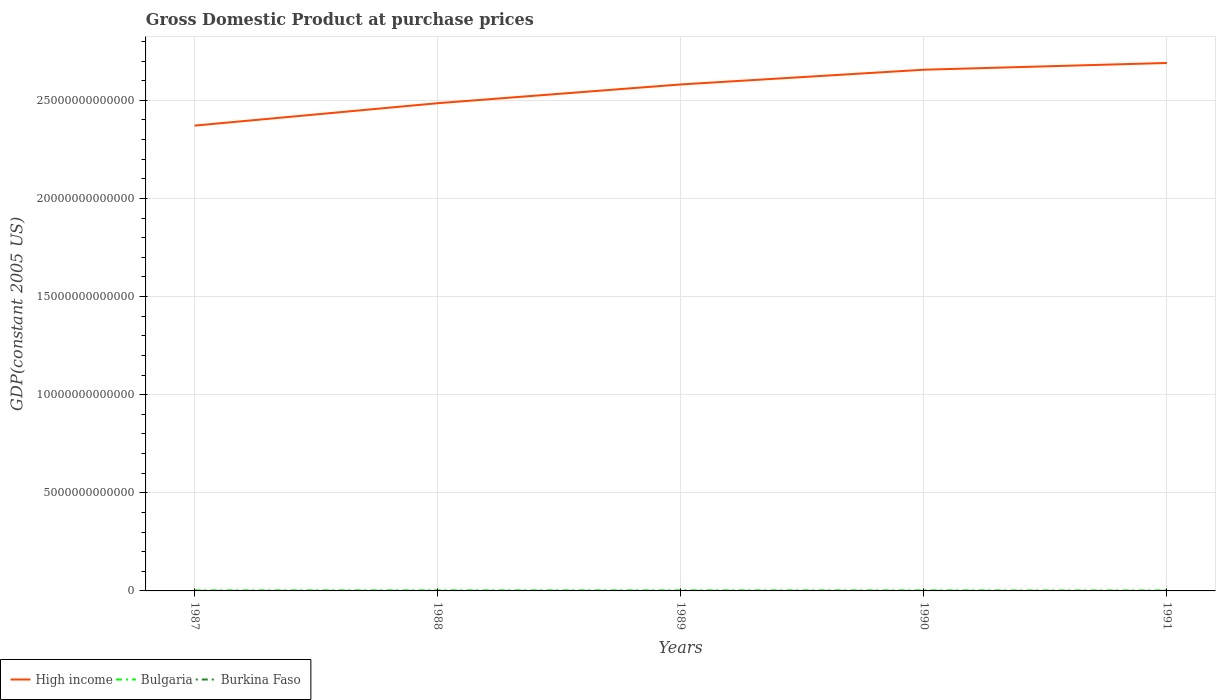Is the number of lines equal to the number of legend labels?
Offer a terse response. Yes. Across all years, what is the maximum GDP at purchase prices in High income?
Provide a short and direct response. 2.37e+13. In which year was the GDP at purchase prices in High income maximum?
Offer a terse response. 1987. What is the total GDP at purchase prices in Bulgaria in the graph?
Your answer should be very brief. 5.53e+09. What is the difference between the highest and the second highest GDP at purchase prices in Burkina Faso?
Make the answer very short. 3.82e+08. How many lines are there?
Ensure brevity in your answer.  3. How many years are there in the graph?
Your answer should be compact. 5. What is the difference between two consecutive major ticks on the Y-axis?
Provide a succinct answer. 5.00e+12. Are the values on the major ticks of Y-axis written in scientific E-notation?
Offer a very short reply. No. Does the graph contain any zero values?
Provide a succinct answer. No. Does the graph contain grids?
Your response must be concise. Yes. How are the legend labels stacked?
Provide a succinct answer. Horizontal. What is the title of the graph?
Provide a succinct answer. Gross Domestic Product at purchase prices. Does "Norway" appear as one of the legend labels in the graph?
Ensure brevity in your answer.  No. What is the label or title of the Y-axis?
Your answer should be very brief. GDP(constant 2005 US). What is the GDP(constant 2005 US) of High income in 1987?
Provide a succinct answer. 2.37e+13. What is the GDP(constant 2005 US) of Bulgaria in 1987?
Offer a terse response. 2.55e+1. What is the GDP(constant 2005 US) of Burkina Faso in 1987?
Your answer should be very brief. 2.23e+09. What is the GDP(constant 2005 US) in High income in 1988?
Your response must be concise. 2.49e+13. What is the GDP(constant 2005 US) of Bulgaria in 1988?
Keep it short and to the point. 2.83e+1. What is the GDP(constant 2005 US) in Burkina Faso in 1988?
Your answer should be very brief. 2.35e+09. What is the GDP(constant 2005 US) in High income in 1989?
Your answer should be compact. 2.58e+13. What is the GDP(constant 2005 US) of Bulgaria in 1989?
Your answer should be compact. 2.74e+1. What is the GDP(constant 2005 US) of Burkina Faso in 1989?
Ensure brevity in your answer.  2.41e+09. What is the GDP(constant 2005 US) of High income in 1990?
Make the answer very short. 2.66e+13. What is the GDP(constant 2005 US) in Bulgaria in 1990?
Provide a succinct answer. 2.49e+1. What is the GDP(constant 2005 US) of Burkina Faso in 1990?
Your answer should be very brief. 2.39e+09. What is the GDP(constant 2005 US) in High income in 1991?
Make the answer very short. 2.69e+13. What is the GDP(constant 2005 US) in Bulgaria in 1991?
Offer a very short reply. 2.28e+1. What is the GDP(constant 2005 US) in Burkina Faso in 1991?
Give a very brief answer. 2.61e+09. Across all years, what is the maximum GDP(constant 2005 US) in High income?
Make the answer very short. 2.69e+13. Across all years, what is the maximum GDP(constant 2005 US) of Bulgaria?
Your answer should be compact. 2.83e+1. Across all years, what is the maximum GDP(constant 2005 US) in Burkina Faso?
Your answer should be very brief. 2.61e+09. Across all years, what is the minimum GDP(constant 2005 US) of High income?
Your response must be concise. 2.37e+13. Across all years, what is the minimum GDP(constant 2005 US) of Bulgaria?
Provide a succinct answer. 2.28e+1. Across all years, what is the minimum GDP(constant 2005 US) in Burkina Faso?
Your answer should be very brief. 2.23e+09. What is the total GDP(constant 2005 US) in High income in the graph?
Make the answer very short. 1.28e+14. What is the total GDP(constant 2005 US) of Bulgaria in the graph?
Provide a short and direct response. 1.29e+11. What is the total GDP(constant 2005 US) of Burkina Faso in the graph?
Your response must be concise. 1.20e+1. What is the difference between the GDP(constant 2005 US) of High income in 1987 and that in 1988?
Ensure brevity in your answer.  -1.14e+12. What is the difference between the GDP(constant 2005 US) in Bulgaria in 1987 and that in 1988?
Offer a terse response. -2.79e+09. What is the difference between the GDP(constant 2005 US) of Burkina Faso in 1987 and that in 1988?
Your answer should be very brief. -1.29e+08. What is the difference between the GDP(constant 2005 US) of High income in 1987 and that in 1989?
Offer a terse response. -2.10e+12. What is the difference between the GDP(constant 2005 US) in Bulgaria in 1987 and that in 1989?
Offer a terse response. -1.86e+09. What is the difference between the GDP(constant 2005 US) of Burkina Faso in 1987 and that in 1989?
Provide a succinct answer. -1.80e+08. What is the difference between the GDP(constant 2005 US) of High income in 1987 and that in 1990?
Provide a succinct answer. -2.85e+12. What is the difference between the GDP(constant 2005 US) in Bulgaria in 1987 and that in 1990?
Your response must be concise. 6.35e+08. What is the difference between the GDP(constant 2005 US) in Burkina Faso in 1987 and that in 1990?
Keep it short and to the point. -1.65e+08. What is the difference between the GDP(constant 2005 US) in High income in 1987 and that in 1991?
Offer a terse response. -3.19e+12. What is the difference between the GDP(constant 2005 US) of Bulgaria in 1987 and that in 1991?
Make the answer very short. 2.74e+09. What is the difference between the GDP(constant 2005 US) in Burkina Faso in 1987 and that in 1991?
Provide a short and direct response. -3.82e+08. What is the difference between the GDP(constant 2005 US) in High income in 1988 and that in 1989?
Keep it short and to the point. -9.55e+11. What is the difference between the GDP(constant 2005 US) in Bulgaria in 1988 and that in 1989?
Give a very brief answer. 9.32e+08. What is the difference between the GDP(constant 2005 US) of Burkina Faso in 1988 and that in 1989?
Your answer should be very brief. -5.06e+07. What is the difference between the GDP(constant 2005 US) of High income in 1988 and that in 1990?
Keep it short and to the point. -1.71e+12. What is the difference between the GDP(constant 2005 US) in Bulgaria in 1988 and that in 1990?
Give a very brief answer. 3.43e+09. What is the difference between the GDP(constant 2005 US) of Burkina Faso in 1988 and that in 1990?
Your answer should be very brief. -3.61e+07. What is the difference between the GDP(constant 2005 US) in High income in 1988 and that in 1991?
Keep it short and to the point. -2.05e+12. What is the difference between the GDP(constant 2005 US) in Bulgaria in 1988 and that in 1991?
Your response must be concise. 5.53e+09. What is the difference between the GDP(constant 2005 US) of Burkina Faso in 1988 and that in 1991?
Provide a short and direct response. -2.53e+08. What is the difference between the GDP(constant 2005 US) of High income in 1989 and that in 1990?
Your answer should be compact. -7.51e+11. What is the difference between the GDP(constant 2005 US) of Bulgaria in 1989 and that in 1990?
Keep it short and to the point. 2.50e+09. What is the difference between the GDP(constant 2005 US) of Burkina Faso in 1989 and that in 1990?
Ensure brevity in your answer.  1.45e+07. What is the difference between the GDP(constant 2005 US) of High income in 1989 and that in 1991?
Provide a short and direct response. -1.09e+12. What is the difference between the GDP(constant 2005 US) in Bulgaria in 1989 and that in 1991?
Provide a succinct answer. 4.60e+09. What is the difference between the GDP(constant 2005 US) in Burkina Faso in 1989 and that in 1991?
Ensure brevity in your answer.  -2.02e+08. What is the difference between the GDP(constant 2005 US) of High income in 1990 and that in 1991?
Your answer should be very brief. -3.44e+11. What is the difference between the GDP(constant 2005 US) of Bulgaria in 1990 and that in 1991?
Give a very brief answer. 2.10e+09. What is the difference between the GDP(constant 2005 US) of Burkina Faso in 1990 and that in 1991?
Your answer should be very brief. -2.17e+08. What is the difference between the GDP(constant 2005 US) in High income in 1987 and the GDP(constant 2005 US) in Bulgaria in 1988?
Give a very brief answer. 2.37e+13. What is the difference between the GDP(constant 2005 US) in High income in 1987 and the GDP(constant 2005 US) in Burkina Faso in 1988?
Provide a short and direct response. 2.37e+13. What is the difference between the GDP(constant 2005 US) of Bulgaria in 1987 and the GDP(constant 2005 US) of Burkina Faso in 1988?
Ensure brevity in your answer.  2.32e+1. What is the difference between the GDP(constant 2005 US) in High income in 1987 and the GDP(constant 2005 US) in Bulgaria in 1989?
Give a very brief answer. 2.37e+13. What is the difference between the GDP(constant 2005 US) in High income in 1987 and the GDP(constant 2005 US) in Burkina Faso in 1989?
Your answer should be compact. 2.37e+13. What is the difference between the GDP(constant 2005 US) of Bulgaria in 1987 and the GDP(constant 2005 US) of Burkina Faso in 1989?
Provide a short and direct response. 2.31e+1. What is the difference between the GDP(constant 2005 US) in High income in 1987 and the GDP(constant 2005 US) in Bulgaria in 1990?
Make the answer very short. 2.37e+13. What is the difference between the GDP(constant 2005 US) in High income in 1987 and the GDP(constant 2005 US) in Burkina Faso in 1990?
Offer a very short reply. 2.37e+13. What is the difference between the GDP(constant 2005 US) of Bulgaria in 1987 and the GDP(constant 2005 US) of Burkina Faso in 1990?
Your answer should be compact. 2.31e+1. What is the difference between the GDP(constant 2005 US) in High income in 1987 and the GDP(constant 2005 US) in Bulgaria in 1991?
Provide a succinct answer. 2.37e+13. What is the difference between the GDP(constant 2005 US) of High income in 1987 and the GDP(constant 2005 US) of Burkina Faso in 1991?
Give a very brief answer. 2.37e+13. What is the difference between the GDP(constant 2005 US) of Bulgaria in 1987 and the GDP(constant 2005 US) of Burkina Faso in 1991?
Make the answer very short. 2.29e+1. What is the difference between the GDP(constant 2005 US) in High income in 1988 and the GDP(constant 2005 US) in Bulgaria in 1989?
Make the answer very short. 2.48e+13. What is the difference between the GDP(constant 2005 US) of High income in 1988 and the GDP(constant 2005 US) of Burkina Faso in 1989?
Offer a very short reply. 2.48e+13. What is the difference between the GDP(constant 2005 US) in Bulgaria in 1988 and the GDP(constant 2005 US) in Burkina Faso in 1989?
Keep it short and to the point. 2.59e+1. What is the difference between the GDP(constant 2005 US) of High income in 1988 and the GDP(constant 2005 US) of Bulgaria in 1990?
Your response must be concise. 2.48e+13. What is the difference between the GDP(constant 2005 US) of High income in 1988 and the GDP(constant 2005 US) of Burkina Faso in 1990?
Offer a terse response. 2.48e+13. What is the difference between the GDP(constant 2005 US) of Bulgaria in 1988 and the GDP(constant 2005 US) of Burkina Faso in 1990?
Keep it short and to the point. 2.59e+1. What is the difference between the GDP(constant 2005 US) in High income in 1988 and the GDP(constant 2005 US) in Bulgaria in 1991?
Offer a very short reply. 2.48e+13. What is the difference between the GDP(constant 2005 US) in High income in 1988 and the GDP(constant 2005 US) in Burkina Faso in 1991?
Keep it short and to the point. 2.48e+13. What is the difference between the GDP(constant 2005 US) in Bulgaria in 1988 and the GDP(constant 2005 US) in Burkina Faso in 1991?
Ensure brevity in your answer.  2.57e+1. What is the difference between the GDP(constant 2005 US) of High income in 1989 and the GDP(constant 2005 US) of Bulgaria in 1990?
Your answer should be compact. 2.58e+13. What is the difference between the GDP(constant 2005 US) of High income in 1989 and the GDP(constant 2005 US) of Burkina Faso in 1990?
Your answer should be compact. 2.58e+13. What is the difference between the GDP(constant 2005 US) in Bulgaria in 1989 and the GDP(constant 2005 US) in Burkina Faso in 1990?
Your answer should be compact. 2.50e+1. What is the difference between the GDP(constant 2005 US) in High income in 1989 and the GDP(constant 2005 US) in Bulgaria in 1991?
Your answer should be compact. 2.58e+13. What is the difference between the GDP(constant 2005 US) of High income in 1989 and the GDP(constant 2005 US) of Burkina Faso in 1991?
Your response must be concise. 2.58e+13. What is the difference between the GDP(constant 2005 US) of Bulgaria in 1989 and the GDP(constant 2005 US) of Burkina Faso in 1991?
Your answer should be compact. 2.48e+1. What is the difference between the GDP(constant 2005 US) of High income in 1990 and the GDP(constant 2005 US) of Bulgaria in 1991?
Give a very brief answer. 2.65e+13. What is the difference between the GDP(constant 2005 US) in High income in 1990 and the GDP(constant 2005 US) in Burkina Faso in 1991?
Your answer should be compact. 2.66e+13. What is the difference between the GDP(constant 2005 US) in Bulgaria in 1990 and the GDP(constant 2005 US) in Burkina Faso in 1991?
Keep it short and to the point. 2.23e+1. What is the average GDP(constant 2005 US) in High income per year?
Ensure brevity in your answer.  2.56e+13. What is the average GDP(constant 2005 US) of Bulgaria per year?
Provide a short and direct response. 2.58e+1. What is the average GDP(constant 2005 US) of Burkina Faso per year?
Offer a terse response. 2.40e+09. In the year 1987, what is the difference between the GDP(constant 2005 US) in High income and GDP(constant 2005 US) in Bulgaria?
Your answer should be very brief. 2.37e+13. In the year 1987, what is the difference between the GDP(constant 2005 US) of High income and GDP(constant 2005 US) of Burkina Faso?
Provide a succinct answer. 2.37e+13. In the year 1987, what is the difference between the GDP(constant 2005 US) of Bulgaria and GDP(constant 2005 US) of Burkina Faso?
Offer a very short reply. 2.33e+1. In the year 1988, what is the difference between the GDP(constant 2005 US) of High income and GDP(constant 2005 US) of Bulgaria?
Your answer should be very brief. 2.48e+13. In the year 1988, what is the difference between the GDP(constant 2005 US) in High income and GDP(constant 2005 US) in Burkina Faso?
Offer a very short reply. 2.48e+13. In the year 1988, what is the difference between the GDP(constant 2005 US) of Bulgaria and GDP(constant 2005 US) of Burkina Faso?
Provide a succinct answer. 2.60e+1. In the year 1989, what is the difference between the GDP(constant 2005 US) of High income and GDP(constant 2005 US) of Bulgaria?
Give a very brief answer. 2.58e+13. In the year 1989, what is the difference between the GDP(constant 2005 US) in High income and GDP(constant 2005 US) in Burkina Faso?
Offer a very short reply. 2.58e+13. In the year 1989, what is the difference between the GDP(constant 2005 US) of Bulgaria and GDP(constant 2005 US) of Burkina Faso?
Your answer should be compact. 2.50e+1. In the year 1990, what is the difference between the GDP(constant 2005 US) in High income and GDP(constant 2005 US) in Bulgaria?
Your answer should be compact. 2.65e+13. In the year 1990, what is the difference between the GDP(constant 2005 US) of High income and GDP(constant 2005 US) of Burkina Faso?
Ensure brevity in your answer.  2.66e+13. In the year 1990, what is the difference between the GDP(constant 2005 US) of Bulgaria and GDP(constant 2005 US) of Burkina Faso?
Keep it short and to the point. 2.25e+1. In the year 1991, what is the difference between the GDP(constant 2005 US) of High income and GDP(constant 2005 US) of Bulgaria?
Offer a very short reply. 2.69e+13. In the year 1991, what is the difference between the GDP(constant 2005 US) of High income and GDP(constant 2005 US) of Burkina Faso?
Give a very brief answer. 2.69e+13. In the year 1991, what is the difference between the GDP(constant 2005 US) in Bulgaria and GDP(constant 2005 US) in Burkina Faso?
Your answer should be compact. 2.02e+1. What is the ratio of the GDP(constant 2005 US) of High income in 1987 to that in 1988?
Make the answer very short. 0.95. What is the ratio of the GDP(constant 2005 US) of Bulgaria in 1987 to that in 1988?
Provide a short and direct response. 0.9. What is the ratio of the GDP(constant 2005 US) of Burkina Faso in 1987 to that in 1988?
Your answer should be compact. 0.95. What is the ratio of the GDP(constant 2005 US) in High income in 1987 to that in 1989?
Keep it short and to the point. 0.92. What is the ratio of the GDP(constant 2005 US) in Bulgaria in 1987 to that in 1989?
Provide a short and direct response. 0.93. What is the ratio of the GDP(constant 2005 US) in Burkina Faso in 1987 to that in 1989?
Offer a very short reply. 0.93. What is the ratio of the GDP(constant 2005 US) of High income in 1987 to that in 1990?
Ensure brevity in your answer.  0.89. What is the ratio of the GDP(constant 2005 US) of Bulgaria in 1987 to that in 1990?
Offer a very short reply. 1.03. What is the ratio of the GDP(constant 2005 US) in Burkina Faso in 1987 to that in 1990?
Keep it short and to the point. 0.93. What is the ratio of the GDP(constant 2005 US) of High income in 1987 to that in 1991?
Offer a terse response. 0.88. What is the ratio of the GDP(constant 2005 US) of Bulgaria in 1987 to that in 1991?
Provide a short and direct response. 1.12. What is the ratio of the GDP(constant 2005 US) of Burkina Faso in 1987 to that in 1991?
Provide a short and direct response. 0.85. What is the ratio of the GDP(constant 2005 US) of Bulgaria in 1988 to that in 1989?
Provide a succinct answer. 1.03. What is the ratio of the GDP(constant 2005 US) in Burkina Faso in 1988 to that in 1989?
Your answer should be compact. 0.98. What is the ratio of the GDP(constant 2005 US) of High income in 1988 to that in 1990?
Provide a short and direct response. 0.94. What is the ratio of the GDP(constant 2005 US) in Bulgaria in 1988 to that in 1990?
Your answer should be very brief. 1.14. What is the ratio of the GDP(constant 2005 US) of Burkina Faso in 1988 to that in 1990?
Your response must be concise. 0.98. What is the ratio of the GDP(constant 2005 US) in High income in 1988 to that in 1991?
Offer a terse response. 0.92. What is the ratio of the GDP(constant 2005 US) of Bulgaria in 1988 to that in 1991?
Offer a terse response. 1.24. What is the ratio of the GDP(constant 2005 US) in Burkina Faso in 1988 to that in 1991?
Make the answer very short. 0.9. What is the ratio of the GDP(constant 2005 US) of High income in 1989 to that in 1990?
Your response must be concise. 0.97. What is the ratio of the GDP(constant 2005 US) of Bulgaria in 1989 to that in 1990?
Give a very brief answer. 1.1. What is the ratio of the GDP(constant 2005 US) in Burkina Faso in 1989 to that in 1990?
Ensure brevity in your answer.  1.01. What is the ratio of the GDP(constant 2005 US) in High income in 1989 to that in 1991?
Offer a terse response. 0.96. What is the ratio of the GDP(constant 2005 US) of Bulgaria in 1989 to that in 1991?
Give a very brief answer. 1.2. What is the ratio of the GDP(constant 2005 US) of Burkina Faso in 1989 to that in 1991?
Ensure brevity in your answer.  0.92. What is the ratio of the GDP(constant 2005 US) of High income in 1990 to that in 1991?
Ensure brevity in your answer.  0.99. What is the ratio of the GDP(constant 2005 US) in Bulgaria in 1990 to that in 1991?
Ensure brevity in your answer.  1.09. What is the ratio of the GDP(constant 2005 US) in Burkina Faso in 1990 to that in 1991?
Give a very brief answer. 0.92. What is the difference between the highest and the second highest GDP(constant 2005 US) of High income?
Your response must be concise. 3.44e+11. What is the difference between the highest and the second highest GDP(constant 2005 US) of Bulgaria?
Offer a very short reply. 9.32e+08. What is the difference between the highest and the second highest GDP(constant 2005 US) of Burkina Faso?
Keep it short and to the point. 2.02e+08. What is the difference between the highest and the lowest GDP(constant 2005 US) of High income?
Provide a succinct answer. 3.19e+12. What is the difference between the highest and the lowest GDP(constant 2005 US) in Bulgaria?
Ensure brevity in your answer.  5.53e+09. What is the difference between the highest and the lowest GDP(constant 2005 US) in Burkina Faso?
Your answer should be compact. 3.82e+08. 